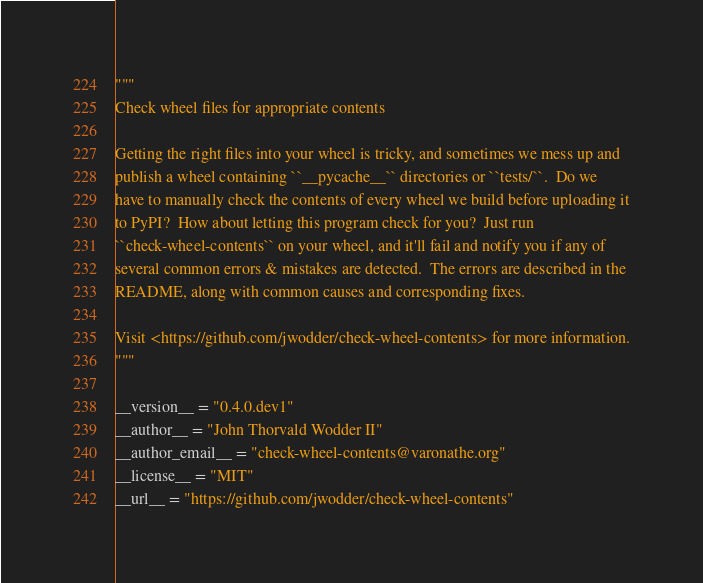Convert code to text. <code><loc_0><loc_0><loc_500><loc_500><_Python_>"""
Check wheel files for appropriate contents

Getting the right files into your wheel is tricky, and sometimes we mess up and
publish a wheel containing ``__pycache__`` directories or ``tests/``.  Do we
have to manually check the contents of every wheel we build before uploading it
to PyPI?  How about letting this program check for you?  Just run
``check-wheel-contents`` on your wheel, and it'll fail and notify you if any of
several common errors & mistakes are detected.  The errors are described in the
README, along with common causes and corresponding fixes.

Visit <https://github.com/jwodder/check-wheel-contents> for more information.
"""

__version__ = "0.4.0.dev1"
__author__ = "John Thorvald Wodder II"
__author_email__ = "check-wheel-contents@varonathe.org"
__license__ = "MIT"
__url__ = "https://github.com/jwodder/check-wheel-contents"
</code> 